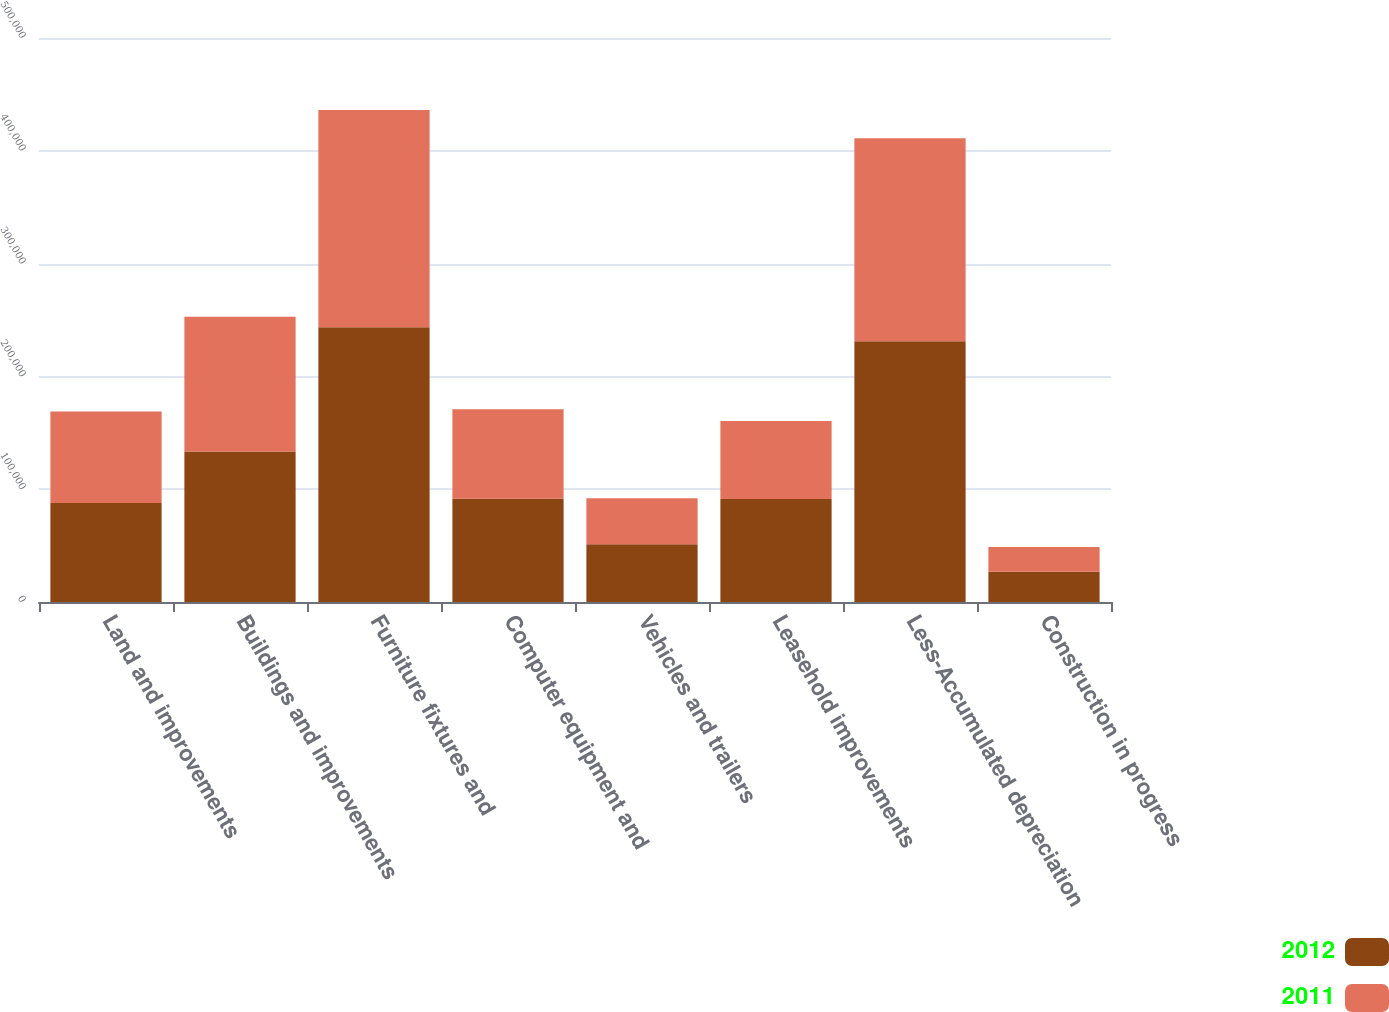<chart> <loc_0><loc_0><loc_500><loc_500><stacked_bar_chart><ecel><fcel>Land and improvements<fcel>Buildings and improvements<fcel>Furniture fixtures and<fcel>Computer equipment and<fcel>Vehicles and trailers<fcel>Leasehold improvements<fcel>Less-Accumulated depreciation<fcel>Construction in progress<nl><fcel>2012<fcel>87720<fcel>133368<fcel>243565<fcel>91588<fcel>51187<fcel>91280<fcel>231130<fcel>26801<nl><fcel>2011<fcel>81170<fcel>119414<fcel>192514<fcel>79195<fcel>40825<fcel>69079<fcel>179950<fcel>21851<nl></chart> 